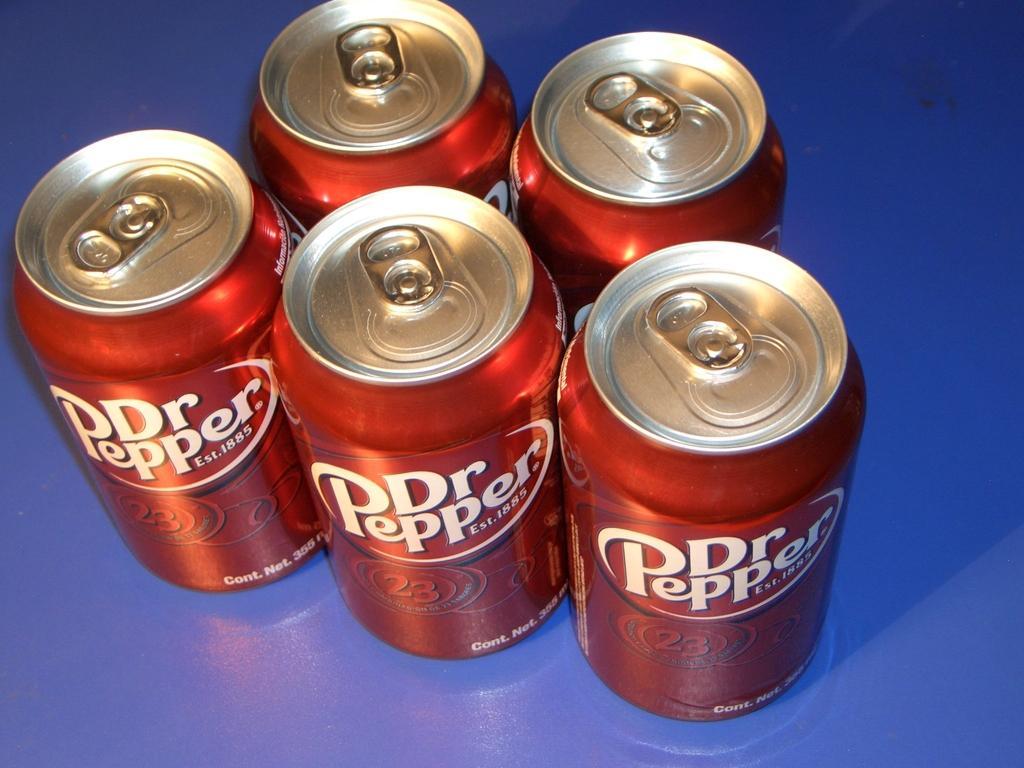What year was dr. pepper established in?
Your answer should be very brief. 1885. What brand of soda is this?
Make the answer very short. Dr pepper. When was dr.pepper established?
Provide a succinct answer. 1885. What brand of soda is shown?
Your answer should be compact. Dr. pepper. 